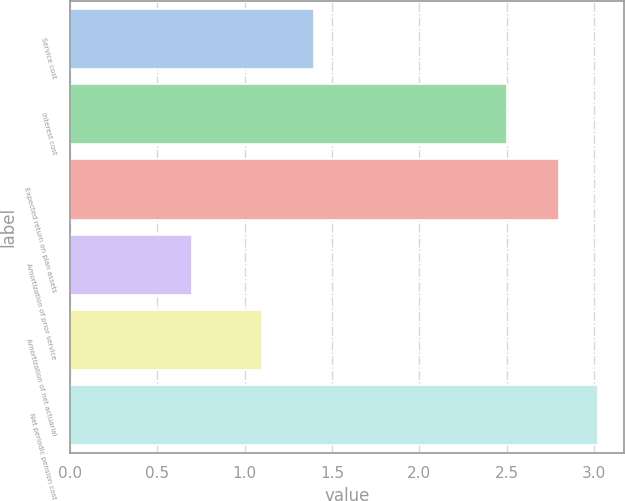Convert chart to OTSL. <chart><loc_0><loc_0><loc_500><loc_500><bar_chart><fcel>Service cost<fcel>Interest cost<fcel>Expected return on plan assets<fcel>Amortization of prior service<fcel>Amortization of net actuarial<fcel>Net periodic pension cost<nl><fcel>1.4<fcel>2.5<fcel>2.8<fcel>0.7<fcel>1.1<fcel>3.02<nl></chart> 